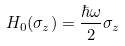Convert formula to latex. <formula><loc_0><loc_0><loc_500><loc_500>H _ { 0 } ( \sigma _ { z } ) = \frac { \hbar { \omega } } { 2 } \sigma _ { z }</formula> 